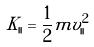<formula> <loc_0><loc_0><loc_500><loc_500>K _ { | | } = \frac { 1 } { 2 } m v _ { | | } ^ { 2 }</formula> 